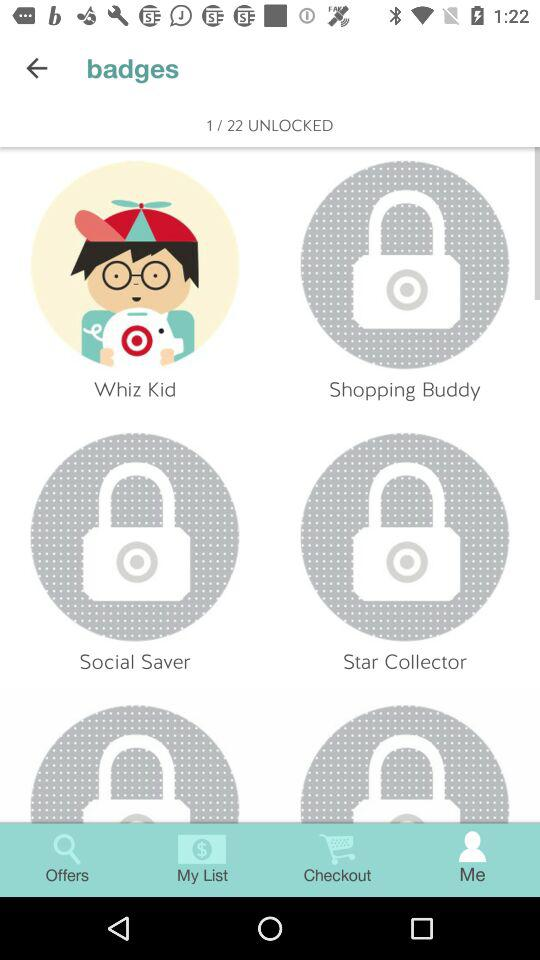How many badges are not unlocked?
Answer the question using a single word or phrase. 21 